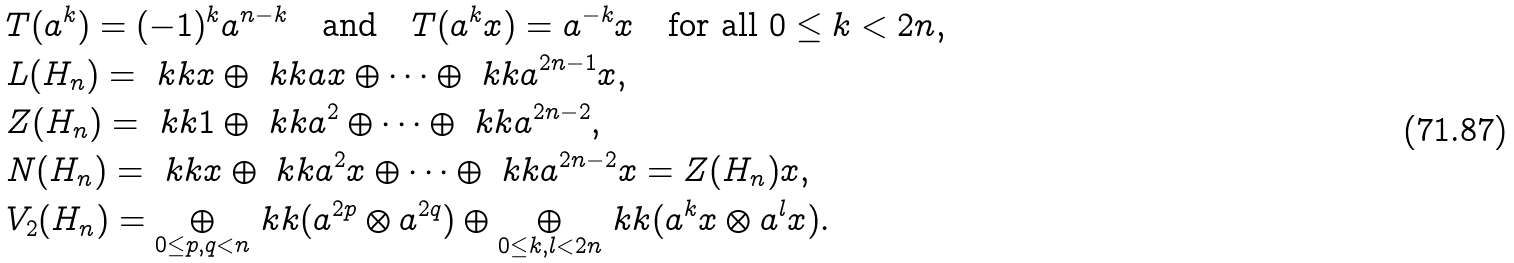<formula> <loc_0><loc_0><loc_500><loc_500>& T ( a ^ { k } ) = ( - 1 ) ^ { k } a ^ { n - k } \quad \text {and} \quad T ( a ^ { k } x ) = a ^ { - k } x \quad \text {for all $0 \leq k <2n$,} \\ & L ( H _ { n } ) = \ k k x \oplus \ k k a x \oplus \cdots \oplus \ k k a ^ { 2 n - 1 } x , \\ & Z ( H _ { n } ) = \ k k 1 \oplus \ k k a ^ { 2 } \oplus \cdots \oplus \ k k a ^ { 2 n - 2 } , \\ & N ( H _ { n } ) = \ k k x \oplus \ k k a ^ { 2 } x \oplus \cdots \oplus \ k k a ^ { 2 n - 2 } x = Z ( H _ { n } ) x , \\ & V _ { 2 } ( H _ { n } ) = \underset { 0 \leq p , q < n } { \oplus } \ k k ( a ^ { 2 p } \otimes a ^ { 2 q } ) \oplus \underset { 0 \leq k , l < 2 n } { \oplus } \ k k ( a ^ { k } x \otimes a ^ { l } x ) .</formula> 